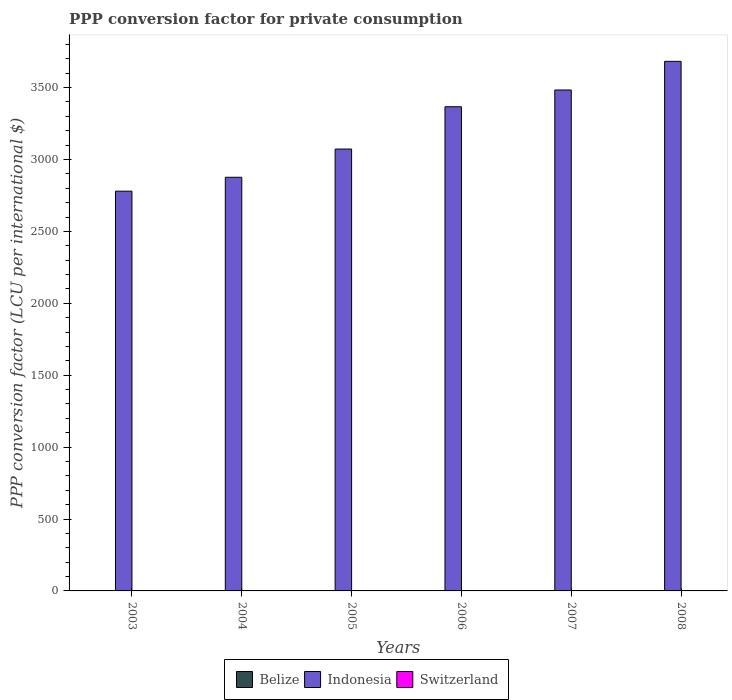How many different coloured bars are there?
Provide a short and direct response. 3. Are the number of bars per tick equal to the number of legend labels?
Make the answer very short. Yes. How many bars are there on the 1st tick from the right?
Ensure brevity in your answer.  3. In how many cases, is the number of bars for a given year not equal to the number of legend labels?
Give a very brief answer. 0. What is the PPP conversion factor for private consumption in Switzerland in 2005?
Provide a succinct answer. 1.85. Across all years, what is the maximum PPP conversion factor for private consumption in Switzerland?
Provide a short and direct response. 1.9. Across all years, what is the minimum PPP conversion factor for private consumption in Indonesia?
Keep it short and to the point. 2779.7. In which year was the PPP conversion factor for private consumption in Indonesia maximum?
Ensure brevity in your answer.  2008. What is the total PPP conversion factor for private consumption in Switzerland in the graph?
Give a very brief answer. 10.92. What is the difference between the PPP conversion factor for private consumption in Indonesia in 2003 and that in 2004?
Offer a terse response. -96.55. What is the difference between the PPP conversion factor for private consumption in Indonesia in 2007 and the PPP conversion factor for private consumption in Belize in 2006?
Provide a short and direct response. 3481.97. What is the average PPP conversion factor for private consumption in Indonesia per year?
Provide a short and direct response. 3210.15. In the year 2007, what is the difference between the PPP conversion factor for private consumption in Switzerland and PPP conversion factor for private consumption in Indonesia?
Ensure brevity in your answer.  -3481.41. In how many years, is the PPP conversion factor for private consumption in Switzerland greater than 3200 LCU?
Offer a terse response. 0. What is the ratio of the PPP conversion factor for private consumption in Indonesia in 2005 to that in 2008?
Make the answer very short. 0.83. What is the difference between the highest and the second highest PPP conversion factor for private consumption in Indonesia?
Offer a terse response. 199.17. What is the difference between the highest and the lowest PPP conversion factor for private consumption in Switzerland?
Provide a succinct answer. 0.21. Is the sum of the PPP conversion factor for private consumption in Switzerland in 2005 and 2008 greater than the maximum PPP conversion factor for private consumption in Belize across all years?
Ensure brevity in your answer.  Yes. What does the 2nd bar from the right in 2008 represents?
Provide a short and direct response. Indonesia. Is it the case that in every year, the sum of the PPP conversion factor for private consumption in Belize and PPP conversion factor for private consumption in Indonesia is greater than the PPP conversion factor for private consumption in Switzerland?
Make the answer very short. Yes. How many bars are there?
Your answer should be compact. 18. Are all the bars in the graph horizontal?
Your answer should be compact. No. Are the values on the major ticks of Y-axis written in scientific E-notation?
Give a very brief answer. No. Does the graph contain any zero values?
Make the answer very short. No. Does the graph contain grids?
Your answer should be very brief. No. How many legend labels are there?
Offer a terse response. 3. How are the legend labels stacked?
Offer a very short reply. Horizontal. What is the title of the graph?
Keep it short and to the point. PPP conversion factor for private consumption. Does "Hong Kong" appear as one of the legend labels in the graph?
Ensure brevity in your answer.  No. What is the label or title of the X-axis?
Give a very brief answer. Years. What is the label or title of the Y-axis?
Provide a succinct answer. PPP conversion factor (LCU per international $). What is the PPP conversion factor (LCU per international $) of Belize in 2003?
Offer a terse response. 1.19. What is the PPP conversion factor (LCU per international $) of Indonesia in 2003?
Offer a terse response. 2779.7. What is the PPP conversion factor (LCU per international $) of Switzerland in 2003?
Your response must be concise. 1.9. What is the PPP conversion factor (LCU per international $) in Belize in 2004?
Your response must be concise. 1.19. What is the PPP conversion factor (LCU per international $) in Indonesia in 2004?
Offer a terse response. 2876.24. What is the PPP conversion factor (LCU per international $) in Switzerland in 2004?
Keep it short and to the point. 1.88. What is the PPP conversion factor (LCU per international $) in Belize in 2005?
Keep it short and to the point. 1.19. What is the PPP conversion factor (LCU per international $) of Indonesia in 2005?
Ensure brevity in your answer.  3072.62. What is the PPP conversion factor (LCU per international $) in Switzerland in 2005?
Give a very brief answer. 1.85. What is the PPP conversion factor (LCU per international $) in Belize in 2006?
Ensure brevity in your answer.  1.2. What is the PPP conversion factor (LCU per international $) in Indonesia in 2006?
Keep it short and to the point. 3366.81. What is the PPP conversion factor (LCU per international $) of Switzerland in 2006?
Ensure brevity in your answer.  1.82. What is the PPP conversion factor (LCU per international $) in Belize in 2007?
Your response must be concise. 1.2. What is the PPP conversion factor (LCU per international $) of Indonesia in 2007?
Make the answer very short. 3483.18. What is the PPP conversion factor (LCU per international $) of Switzerland in 2007?
Provide a succinct answer. 1.77. What is the PPP conversion factor (LCU per international $) of Belize in 2008?
Your answer should be compact. 1.23. What is the PPP conversion factor (LCU per international $) in Indonesia in 2008?
Your answer should be compact. 3682.34. What is the PPP conversion factor (LCU per international $) of Switzerland in 2008?
Your response must be concise. 1.7. Across all years, what is the maximum PPP conversion factor (LCU per international $) in Belize?
Your answer should be very brief. 1.23. Across all years, what is the maximum PPP conversion factor (LCU per international $) in Indonesia?
Your answer should be very brief. 3682.34. Across all years, what is the maximum PPP conversion factor (LCU per international $) of Switzerland?
Give a very brief answer. 1.9. Across all years, what is the minimum PPP conversion factor (LCU per international $) in Belize?
Offer a very short reply. 1.19. Across all years, what is the minimum PPP conversion factor (LCU per international $) of Indonesia?
Your answer should be very brief. 2779.7. Across all years, what is the minimum PPP conversion factor (LCU per international $) of Switzerland?
Your answer should be compact. 1.7. What is the total PPP conversion factor (LCU per international $) of Belize in the graph?
Give a very brief answer. 7.2. What is the total PPP conversion factor (LCU per international $) in Indonesia in the graph?
Provide a succinct answer. 1.93e+04. What is the total PPP conversion factor (LCU per international $) in Switzerland in the graph?
Keep it short and to the point. 10.92. What is the difference between the PPP conversion factor (LCU per international $) of Belize in 2003 and that in 2004?
Your answer should be compact. -0. What is the difference between the PPP conversion factor (LCU per international $) of Indonesia in 2003 and that in 2004?
Offer a very short reply. -96.55. What is the difference between the PPP conversion factor (LCU per international $) in Switzerland in 2003 and that in 2004?
Your answer should be very brief. 0.02. What is the difference between the PPP conversion factor (LCU per international $) of Belize in 2003 and that in 2005?
Provide a short and direct response. -0.01. What is the difference between the PPP conversion factor (LCU per international $) of Indonesia in 2003 and that in 2005?
Provide a short and direct response. -292.92. What is the difference between the PPP conversion factor (LCU per international $) of Switzerland in 2003 and that in 2005?
Provide a short and direct response. 0.05. What is the difference between the PPP conversion factor (LCU per international $) of Belize in 2003 and that in 2006?
Ensure brevity in your answer.  -0.02. What is the difference between the PPP conversion factor (LCU per international $) in Indonesia in 2003 and that in 2006?
Your answer should be compact. -587.12. What is the difference between the PPP conversion factor (LCU per international $) of Switzerland in 2003 and that in 2006?
Your answer should be very brief. 0.09. What is the difference between the PPP conversion factor (LCU per international $) of Belize in 2003 and that in 2007?
Make the answer very short. -0.01. What is the difference between the PPP conversion factor (LCU per international $) of Indonesia in 2003 and that in 2007?
Your answer should be compact. -703.48. What is the difference between the PPP conversion factor (LCU per international $) of Switzerland in 2003 and that in 2007?
Keep it short and to the point. 0.14. What is the difference between the PPP conversion factor (LCU per international $) in Belize in 2003 and that in 2008?
Offer a very short reply. -0.04. What is the difference between the PPP conversion factor (LCU per international $) of Indonesia in 2003 and that in 2008?
Offer a terse response. -902.65. What is the difference between the PPP conversion factor (LCU per international $) of Switzerland in 2003 and that in 2008?
Provide a succinct answer. 0.21. What is the difference between the PPP conversion factor (LCU per international $) of Belize in 2004 and that in 2005?
Keep it short and to the point. -0. What is the difference between the PPP conversion factor (LCU per international $) of Indonesia in 2004 and that in 2005?
Provide a short and direct response. -196.38. What is the difference between the PPP conversion factor (LCU per international $) in Switzerland in 2004 and that in 2005?
Your answer should be compact. 0.03. What is the difference between the PPP conversion factor (LCU per international $) in Belize in 2004 and that in 2006?
Make the answer very short. -0.01. What is the difference between the PPP conversion factor (LCU per international $) of Indonesia in 2004 and that in 2006?
Provide a succinct answer. -490.57. What is the difference between the PPP conversion factor (LCU per international $) in Switzerland in 2004 and that in 2006?
Your answer should be very brief. 0.07. What is the difference between the PPP conversion factor (LCU per international $) of Belize in 2004 and that in 2007?
Offer a terse response. -0.01. What is the difference between the PPP conversion factor (LCU per international $) of Indonesia in 2004 and that in 2007?
Your answer should be compact. -606.93. What is the difference between the PPP conversion factor (LCU per international $) in Switzerland in 2004 and that in 2007?
Ensure brevity in your answer.  0.12. What is the difference between the PPP conversion factor (LCU per international $) of Belize in 2004 and that in 2008?
Your answer should be very brief. -0.04. What is the difference between the PPP conversion factor (LCU per international $) of Indonesia in 2004 and that in 2008?
Ensure brevity in your answer.  -806.1. What is the difference between the PPP conversion factor (LCU per international $) in Switzerland in 2004 and that in 2008?
Your answer should be very brief. 0.19. What is the difference between the PPP conversion factor (LCU per international $) of Belize in 2005 and that in 2006?
Ensure brevity in your answer.  -0.01. What is the difference between the PPP conversion factor (LCU per international $) of Indonesia in 2005 and that in 2006?
Offer a terse response. -294.19. What is the difference between the PPP conversion factor (LCU per international $) in Switzerland in 2005 and that in 2006?
Keep it short and to the point. 0.03. What is the difference between the PPP conversion factor (LCU per international $) in Belize in 2005 and that in 2007?
Your response must be concise. -0.01. What is the difference between the PPP conversion factor (LCU per international $) in Indonesia in 2005 and that in 2007?
Your answer should be very brief. -410.55. What is the difference between the PPP conversion factor (LCU per international $) of Switzerland in 2005 and that in 2007?
Give a very brief answer. 0.08. What is the difference between the PPP conversion factor (LCU per international $) in Belize in 2005 and that in 2008?
Your answer should be compact. -0.03. What is the difference between the PPP conversion factor (LCU per international $) of Indonesia in 2005 and that in 2008?
Your response must be concise. -609.72. What is the difference between the PPP conversion factor (LCU per international $) in Switzerland in 2005 and that in 2008?
Your answer should be very brief. 0.15. What is the difference between the PPP conversion factor (LCU per international $) of Belize in 2006 and that in 2007?
Offer a terse response. 0.01. What is the difference between the PPP conversion factor (LCU per international $) of Indonesia in 2006 and that in 2007?
Offer a terse response. -116.36. What is the difference between the PPP conversion factor (LCU per international $) in Switzerland in 2006 and that in 2007?
Provide a succinct answer. 0.05. What is the difference between the PPP conversion factor (LCU per international $) in Belize in 2006 and that in 2008?
Your answer should be very brief. -0.02. What is the difference between the PPP conversion factor (LCU per international $) of Indonesia in 2006 and that in 2008?
Your answer should be compact. -315.53. What is the difference between the PPP conversion factor (LCU per international $) of Switzerland in 2006 and that in 2008?
Ensure brevity in your answer.  0.12. What is the difference between the PPP conversion factor (LCU per international $) in Belize in 2007 and that in 2008?
Your answer should be compact. -0.03. What is the difference between the PPP conversion factor (LCU per international $) in Indonesia in 2007 and that in 2008?
Provide a short and direct response. -199.17. What is the difference between the PPP conversion factor (LCU per international $) of Switzerland in 2007 and that in 2008?
Ensure brevity in your answer.  0.07. What is the difference between the PPP conversion factor (LCU per international $) of Belize in 2003 and the PPP conversion factor (LCU per international $) of Indonesia in 2004?
Provide a short and direct response. -2875.06. What is the difference between the PPP conversion factor (LCU per international $) in Belize in 2003 and the PPP conversion factor (LCU per international $) in Switzerland in 2004?
Ensure brevity in your answer.  -0.7. What is the difference between the PPP conversion factor (LCU per international $) of Indonesia in 2003 and the PPP conversion factor (LCU per international $) of Switzerland in 2004?
Your answer should be very brief. 2777.81. What is the difference between the PPP conversion factor (LCU per international $) in Belize in 2003 and the PPP conversion factor (LCU per international $) in Indonesia in 2005?
Provide a succinct answer. -3071.44. What is the difference between the PPP conversion factor (LCU per international $) in Belize in 2003 and the PPP conversion factor (LCU per international $) in Switzerland in 2005?
Keep it short and to the point. -0.66. What is the difference between the PPP conversion factor (LCU per international $) of Indonesia in 2003 and the PPP conversion factor (LCU per international $) of Switzerland in 2005?
Keep it short and to the point. 2777.85. What is the difference between the PPP conversion factor (LCU per international $) of Belize in 2003 and the PPP conversion factor (LCU per international $) of Indonesia in 2006?
Your answer should be very brief. -3365.63. What is the difference between the PPP conversion factor (LCU per international $) of Belize in 2003 and the PPP conversion factor (LCU per international $) of Switzerland in 2006?
Your response must be concise. -0.63. What is the difference between the PPP conversion factor (LCU per international $) in Indonesia in 2003 and the PPP conversion factor (LCU per international $) in Switzerland in 2006?
Give a very brief answer. 2777.88. What is the difference between the PPP conversion factor (LCU per international $) in Belize in 2003 and the PPP conversion factor (LCU per international $) in Indonesia in 2007?
Offer a terse response. -3481.99. What is the difference between the PPP conversion factor (LCU per international $) in Belize in 2003 and the PPP conversion factor (LCU per international $) in Switzerland in 2007?
Offer a terse response. -0.58. What is the difference between the PPP conversion factor (LCU per international $) of Indonesia in 2003 and the PPP conversion factor (LCU per international $) of Switzerland in 2007?
Your answer should be very brief. 2777.93. What is the difference between the PPP conversion factor (LCU per international $) of Belize in 2003 and the PPP conversion factor (LCU per international $) of Indonesia in 2008?
Provide a succinct answer. -3681.16. What is the difference between the PPP conversion factor (LCU per international $) of Belize in 2003 and the PPP conversion factor (LCU per international $) of Switzerland in 2008?
Your answer should be compact. -0.51. What is the difference between the PPP conversion factor (LCU per international $) of Indonesia in 2003 and the PPP conversion factor (LCU per international $) of Switzerland in 2008?
Ensure brevity in your answer.  2778. What is the difference between the PPP conversion factor (LCU per international $) of Belize in 2004 and the PPP conversion factor (LCU per international $) of Indonesia in 2005?
Your answer should be very brief. -3071.43. What is the difference between the PPP conversion factor (LCU per international $) in Belize in 2004 and the PPP conversion factor (LCU per international $) in Switzerland in 2005?
Offer a terse response. -0.66. What is the difference between the PPP conversion factor (LCU per international $) of Indonesia in 2004 and the PPP conversion factor (LCU per international $) of Switzerland in 2005?
Keep it short and to the point. 2874.4. What is the difference between the PPP conversion factor (LCU per international $) of Belize in 2004 and the PPP conversion factor (LCU per international $) of Indonesia in 2006?
Your answer should be very brief. -3365.62. What is the difference between the PPP conversion factor (LCU per international $) in Belize in 2004 and the PPP conversion factor (LCU per international $) in Switzerland in 2006?
Your answer should be very brief. -0.63. What is the difference between the PPP conversion factor (LCU per international $) in Indonesia in 2004 and the PPP conversion factor (LCU per international $) in Switzerland in 2006?
Provide a succinct answer. 2874.43. What is the difference between the PPP conversion factor (LCU per international $) of Belize in 2004 and the PPP conversion factor (LCU per international $) of Indonesia in 2007?
Offer a terse response. -3481.99. What is the difference between the PPP conversion factor (LCU per international $) of Belize in 2004 and the PPP conversion factor (LCU per international $) of Switzerland in 2007?
Provide a succinct answer. -0.58. What is the difference between the PPP conversion factor (LCU per international $) of Indonesia in 2004 and the PPP conversion factor (LCU per international $) of Switzerland in 2007?
Give a very brief answer. 2874.48. What is the difference between the PPP conversion factor (LCU per international $) in Belize in 2004 and the PPP conversion factor (LCU per international $) in Indonesia in 2008?
Your response must be concise. -3681.15. What is the difference between the PPP conversion factor (LCU per international $) of Belize in 2004 and the PPP conversion factor (LCU per international $) of Switzerland in 2008?
Make the answer very short. -0.5. What is the difference between the PPP conversion factor (LCU per international $) of Indonesia in 2004 and the PPP conversion factor (LCU per international $) of Switzerland in 2008?
Ensure brevity in your answer.  2874.55. What is the difference between the PPP conversion factor (LCU per international $) of Belize in 2005 and the PPP conversion factor (LCU per international $) of Indonesia in 2006?
Your answer should be very brief. -3365.62. What is the difference between the PPP conversion factor (LCU per international $) of Belize in 2005 and the PPP conversion factor (LCU per international $) of Switzerland in 2006?
Your answer should be compact. -0.62. What is the difference between the PPP conversion factor (LCU per international $) in Indonesia in 2005 and the PPP conversion factor (LCU per international $) in Switzerland in 2006?
Give a very brief answer. 3070.8. What is the difference between the PPP conversion factor (LCU per international $) of Belize in 2005 and the PPP conversion factor (LCU per international $) of Indonesia in 2007?
Your answer should be very brief. -3481.98. What is the difference between the PPP conversion factor (LCU per international $) of Belize in 2005 and the PPP conversion factor (LCU per international $) of Switzerland in 2007?
Your answer should be very brief. -0.57. What is the difference between the PPP conversion factor (LCU per international $) in Indonesia in 2005 and the PPP conversion factor (LCU per international $) in Switzerland in 2007?
Provide a short and direct response. 3070.86. What is the difference between the PPP conversion factor (LCU per international $) of Belize in 2005 and the PPP conversion factor (LCU per international $) of Indonesia in 2008?
Provide a succinct answer. -3681.15. What is the difference between the PPP conversion factor (LCU per international $) of Belize in 2005 and the PPP conversion factor (LCU per international $) of Switzerland in 2008?
Your response must be concise. -0.5. What is the difference between the PPP conversion factor (LCU per international $) in Indonesia in 2005 and the PPP conversion factor (LCU per international $) in Switzerland in 2008?
Offer a very short reply. 3070.93. What is the difference between the PPP conversion factor (LCU per international $) in Belize in 2006 and the PPP conversion factor (LCU per international $) in Indonesia in 2007?
Offer a terse response. -3481.97. What is the difference between the PPP conversion factor (LCU per international $) of Belize in 2006 and the PPP conversion factor (LCU per international $) of Switzerland in 2007?
Make the answer very short. -0.56. What is the difference between the PPP conversion factor (LCU per international $) of Indonesia in 2006 and the PPP conversion factor (LCU per international $) of Switzerland in 2007?
Ensure brevity in your answer.  3365.05. What is the difference between the PPP conversion factor (LCU per international $) in Belize in 2006 and the PPP conversion factor (LCU per international $) in Indonesia in 2008?
Provide a succinct answer. -3681.14. What is the difference between the PPP conversion factor (LCU per international $) of Belize in 2006 and the PPP conversion factor (LCU per international $) of Switzerland in 2008?
Ensure brevity in your answer.  -0.49. What is the difference between the PPP conversion factor (LCU per international $) of Indonesia in 2006 and the PPP conversion factor (LCU per international $) of Switzerland in 2008?
Provide a short and direct response. 3365.12. What is the difference between the PPP conversion factor (LCU per international $) of Belize in 2007 and the PPP conversion factor (LCU per international $) of Indonesia in 2008?
Ensure brevity in your answer.  -3681.15. What is the difference between the PPP conversion factor (LCU per international $) of Belize in 2007 and the PPP conversion factor (LCU per international $) of Switzerland in 2008?
Your answer should be very brief. -0.5. What is the difference between the PPP conversion factor (LCU per international $) of Indonesia in 2007 and the PPP conversion factor (LCU per international $) of Switzerland in 2008?
Keep it short and to the point. 3481.48. What is the average PPP conversion factor (LCU per international $) in Indonesia per year?
Ensure brevity in your answer.  3210.15. What is the average PPP conversion factor (LCU per international $) in Switzerland per year?
Your response must be concise. 1.82. In the year 2003, what is the difference between the PPP conversion factor (LCU per international $) of Belize and PPP conversion factor (LCU per international $) of Indonesia?
Offer a very short reply. -2778.51. In the year 2003, what is the difference between the PPP conversion factor (LCU per international $) of Belize and PPP conversion factor (LCU per international $) of Switzerland?
Provide a short and direct response. -0.72. In the year 2003, what is the difference between the PPP conversion factor (LCU per international $) of Indonesia and PPP conversion factor (LCU per international $) of Switzerland?
Make the answer very short. 2777.79. In the year 2004, what is the difference between the PPP conversion factor (LCU per international $) of Belize and PPP conversion factor (LCU per international $) of Indonesia?
Give a very brief answer. -2875.05. In the year 2004, what is the difference between the PPP conversion factor (LCU per international $) in Belize and PPP conversion factor (LCU per international $) in Switzerland?
Give a very brief answer. -0.69. In the year 2004, what is the difference between the PPP conversion factor (LCU per international $) in Indonesia and PPP conversion factor (LCU per international $) in Switzerland?
Give a very brief answer. 2874.36. In the year 2005, what is the difference between the PPP conversion factor (LCU per international $) of Belize and PPP conversion factor (LCU per international $) of Indonesia?
Offer a very short reply. -3071.43. In the year 2005, what is the difference between the PPP conversion factor (LCU per international $) of Belize and PPP conversion factor (LCU per international $) of Switzerland?
Provide a short and direct response. -0.66. In the year 2005, what is the difference between the PPP conversion factor (LCU per international $) of Indonesia and PPP conversion factor (LCU per international $) of Switzerland?
Provide a short and direct response. 3070.77. In the year 2006, what is the difference between the PPP conversion factor (LCU per international $) in Belize and PPP conversion factor (LCU per international $) in Indonesia?
Provide a short and direct response. -3365.61. In the year 2006, what is the difference between the PPP conversion factor (LCU per international $) in Belize and PPP conversion factor (LCU per international $) in Switzerland?
Give a very brief answer. -0.61. In the year 2006, what is the difference between the PPP conversion factor (LCU per international $) in Indonesia and PPP conversion factor (LCU per international $) in Switzerland?
Provide a succinct answer. 3365. In the year 2007, what is the difference between the PPP conversion factor (LCU per international $) in Belize and PPP conversion factor (LCU per international $) in Indonesia?
Give a very brief answer. -3481.98. In the year 2007, what is the difference between the PPP conversion factor (LCU per international $) of Belize and PPP conversion factor (LCU per international $) of Switzerland?
Your answer should be very brief. -0.57. In the year 2007, what is the difference between the PPP conversion factor (LCU per international $) in Indonesia and PPP conversion factor (LCU per international $) in Switzerland?
Keep it short and to the point. 3481.41. In the year 2008, what is the difference between the PPP conversion factor (LCU per international $) in Belize and PPP conversion factor (LCU per international $) in Indonesia?
Provide a short and direct response. -3681.12. In the year 2008, what is the difference between the PPP conversion factor (LCU per international $) of Belize and PPP conversion factor (LCU per international $) of Switzerland?
Your answer should be very brief. -0.47. In the year 2008, what is the difference between the PPP conversion factor (LCU per international $) of Indonesia and PPP conversion factor (LCU per international $) of Switzerland?
Your response must be concise. 3680.65. What is the ratio of the PPP conversion factor (LCU per international $) in Belize in 2003 to that in 2004?
Your answer should be compact. 1. What is the ratio of the PPP conversion factor (LCU per international $) of Indonesia in 2003 to that in 2004?
Offer a very short reply. 0.97. What is the ratio of the PPP conversion factor (LCU per international $) of Switzerland in 2003 to that in 2004?
Give a very brief answer. 1.01. What is the ratio of the PPP conversion factor (LCU per international $) of Belize in 2003 to that in 2005?
Provide a short and direct response. 0.99. What is the ratio of the PPP conversion factor (LCU per international $) of Indonesia in 2003 to that in 2005?
Give a very brief answer. 0.9. What is the ratio of the PPP conversion factor (LCU per international $) in Switzerland in 2003 to that in 2005?
Your answer should be compact. 1.03. What is the ratio of the PPP conversion factor (LCU per international $) in Indonesia in 2003 to that in 2006?
Your response must be concise. 0.83. What is the ratio of the PPP conversion factor (LCU per international $) in Switzerland in 2003 to that in 2006?
Your response must be concise. 1.05. What is the ratio of the PPP conversion factor (LCU per international $) in Belize in 2003 to that in 2007?
Provide a succinct answer. 0.99. What is the ratio of the PPP conversion factor (LCU per international $) in Indonesia in 2003 to that in 2007?
Your response must be concise. 0.8. What is the ratio of the PPP conversion factor (LCU per international $) of Switzerland in 2003 to that in 2007?
Provide a short and direct response. 1.08. What is the ratio of the PPP conversion factor (LCU per international $) of Belize in 2003 to that in 2008?
Offer a very short reply. 0.97. What is the ratio of the PPP conversion factor (LCU per international $) in Indonesia in 2003 to that in 2008?
Give a very brief answer. 0.75. What is the ratio of the PPP conversion factor (LCU per international $) of Switzerland in 2003 to that in 2008?
Your answer should be compact. 1.12. What is the ratio of the PPP conversion factor (LCU per international $) in Belize in 2004 to that in 2005?
Your answer should be very brief. 1. What is the ratio of the PPP conversion factor (LCU per international $) in Indonesia in 2004 to that in 2005?
Provide a short and direct response. 0.94. What is the ratio of the PPP conversion factor (LCU per international $) in Switzerland in 2004 to that in 2005?
Offer a very short reply. 1.02. What is the ratio of the PPP conversion factor (LCU per international $) in Indonesia in 2004 to that in 2006?
Offer a very short reply. 0.85. What is the ratio of the PPP conversion factor (LCU per international $) of Switzerland in 2004 to that in 2006?
Your response must be concise. 1.04. What is the ratio of the PPP conversion factor (LCU per international $) in Belize in 2004 to that in 2007?
Your answer should be compact. 0.99. What is the ratio of the PPP conversion factor (LCU per international $) of Indonesia in 2004 to that in 2007?
Give a very brief answer. 0.83. What is the ratio of the PPP conversion factor (LCU per international $) in Switzerland in 2004 to that in 2007?
Provide a short and direct response. 1.07. What is the ratio of the PPP conversion factor (LCU per international $) in Belize in 2004 to that in 2008?
Your answer should be compact. 0.97. What is the ratio of the PPP conversion factor (LCU per international $) in Indonesia in 2004 to that in 2008?
Offer a very short reply. 0.78. What is the ratio of the PPP conversion factor (LCU per international $) in Switzerland in 2004 to that in 2008?
Make the answer very short. 1.11. What is the ratio of the PPP conversion factor (LCU per international $) in Belize in 2005 to that in 2006?
Your answer should be very brief. 0.99. What is the ratio of the PPP conversion factor (LCU per international $) in Indonesia in 2005 to that in 2006?
Your answer should be compact. 0.91. What is the ratio of the PPP conversion factor (LCU per international $) of Switzerland in 2005 to that in 2006?
Your answer should be compact. 1.02. What is the ratio of the PPP conversion factor (LCU per international $) of Indonesia in 2005 to that in 2007?
Your answer should be compact. 0.88. What is the ratio of the PPP conversion factor (LCU per international $) in Switzerland in 2005 to that in 2007?
Provide a short and direct response. 1.05. What is the ratio of the PPP conversion factor (LCU per international $) of Belize in 2005 to that in 2008?
Make the answer very short. 0.97. What is the ratio of the PPP conversion factor (LCU per international $) in Indonesia in 2005 to that in 2008?
Provide a succinct answer. 0.83. What is the ratio of the PPP conversion factor (LCU per international $) in Switzerland in 2005 to that in 2008?
Offer a terse response. 1.09. What is the ratio of the PPP conversion factor (LCU per international $) in Belize in 2006 to that in 2007?
Provide a succinct answer. 1.01. What is the ratio of the PPP conversion factor (LCU per international $) of Indonesia in 2006 to that in 2007?
Give a very brief answer. 0.97. What is the ratio of the PPP conversion factor (LCU per international $) of Switzerland in 2006 to that in 2007?
Keep it short and to the point. 1.03. What is the ratio of the PPP conversion factor (LCU per international $) in Belize in 2006 to that in 2008?
Provide a succinct answer. 0.98. What is the ratio of the PPP conversion factor (LCU per international $) of Indonesia in 2006 to that in 2008?
Offer a terse response. 0.91. What is the ratio of the PPP conversion factor (LCU per international $) of Switzerland in 2006 to that in 2008?
Your response must be concise. 1.07. What is the ratio of the PPP conversion factor (LCU per international $) of Indonesia in 2007 to that in 2008?
Provide a short and direct response. 0.95. What is the ratio of the PPP conversion factor (LCU per international $) of Switzerland in 2007 to that in 2008?
Provide a succinct answer. 1.04. What is the difference between the highest and the second highest PPP conversion factor (LCU per international $) in Belize?
Provide a short and direct response. 0.02. What is the difference between the highest and the second highest PPP conversion factor (LCU per international $) in Indonesia?
Your answer should be very brief. 199.17. What is the difference between the highest and the second highest PPP conversion factor (LCU per international $) of Switzerland?
Keep it short and to the point. 0.02. What is the difference between the highest and the lowest PPP conversion factor (LCU per international $) of Belize?
Your answer should be very brief. 0.04. What is the difference between the highest and the lowest PPP conversion factor (LCU per international $) of Indonesia?
Give a very brief answer. 902.65. What is the difference between the highest and the lowest PPP conversion factor (LCU per international $) in Switzerland?
Provide a short and direct response. 0.21. 